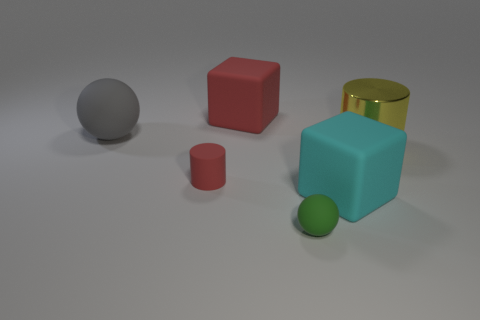Add 4 large blue shiny things. How many objects exist? 10 Subtract all gray balls. How many balls are left? 1 Subtract 1 cylinders. How many cylinders are left? 1 Subtract all spheres. How many objects are left? 4 Subtract 0 yellow spheres. How many objects are left? 6 Subtract all red balls. Subtract all red cubes. How many balls are left? 2 Subtract all large cylinders. Subtract all large gray things. How many objects are left? 4 Add 2 rubber blocks. How many rubber blocks are left? 4 Add 4 cyan rubber cubes. How many cyan rubber cubes exist? 5 